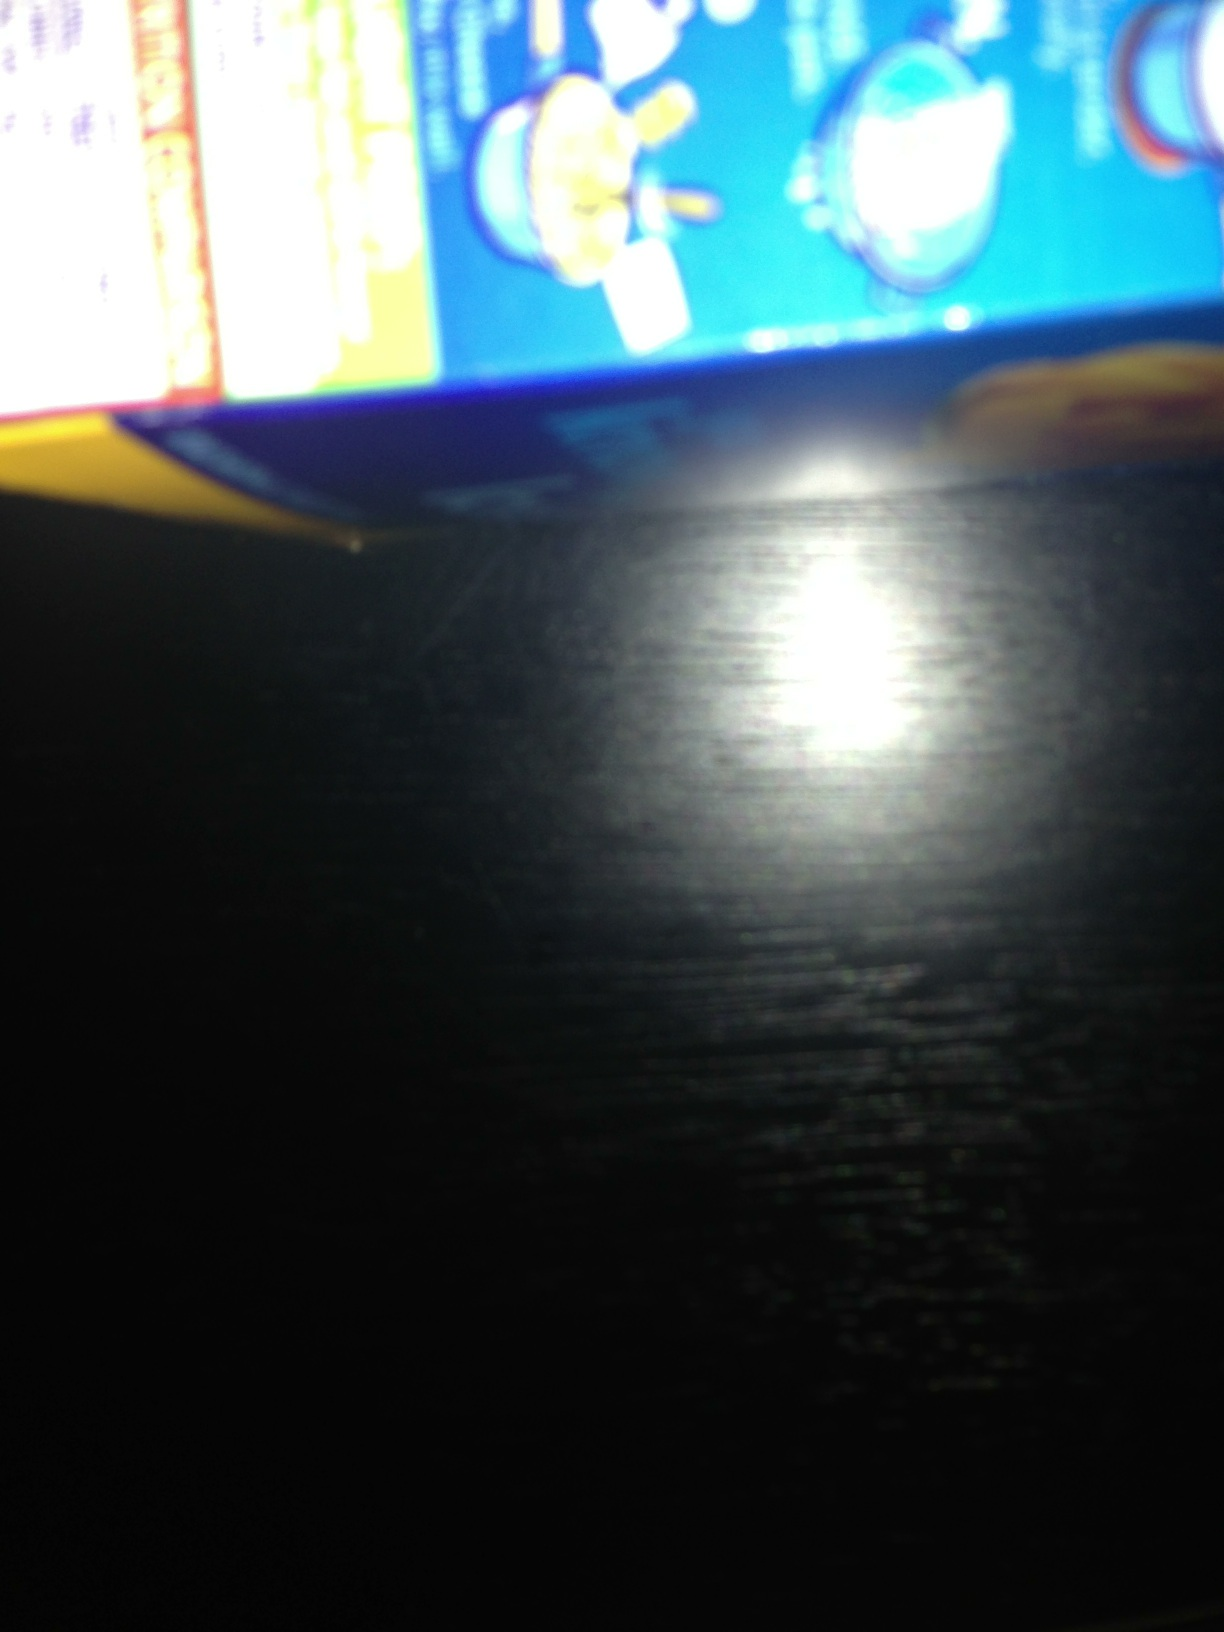What are the nutritional values indicated on this box? The nutritional values are not readable due to the blurriness of the image. For an accurate read, please retake the photo ensuring that the text is in focus and legible. Is it common to find pictorial representations on food packaging? Yes, it's common to find pictorial representations on food packaging. These images often illustrate the cooking process, serving suggestions, or highlight key ingredients. They help in making the cooking process easier to understand and provide a visual expectation of the final dish. Describe a scenario where having clear cooking instructions on a package is crucial. Having clear cooking instructions on a package is crucial in scenarios like preparing a meal for someone with dietary restrictions or allergies. Accurate instructions ensure the food is cooked perfectly, preserving its nutritional value and preventing any health issues. For instance, if someone is cooking a gluten-free meal, unclear instructions might lead to improper preparation, causing cross-contamination or undercooking, which can negate the health benefits and safety of the meal. 